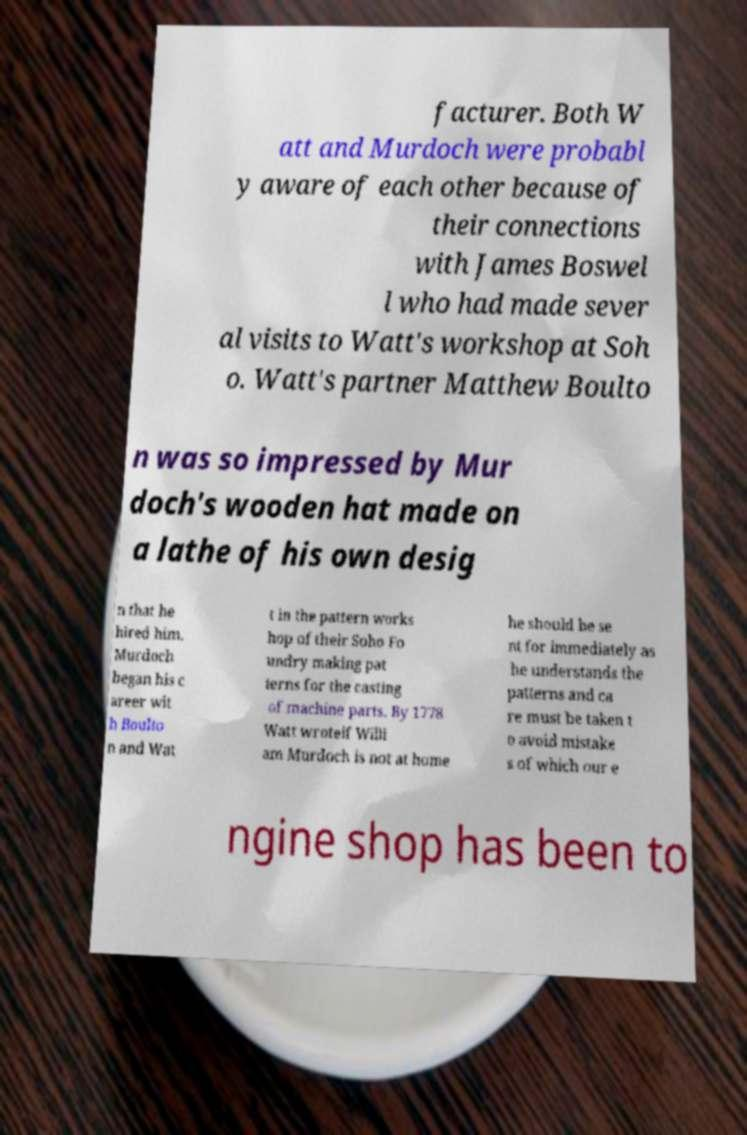There's text embedded in this image that I need extracted. Can you transcribe it verbatim? facturer. Both W att and Murdoch were probabl y aware of each other because of their connections with James Boswel l who had made sever al visits to Watt's workshop at Soh o. Watt's partner Matthew Boulto n was so impressed by Mur doch's wooden hat made on a lathe of his own desig n that he hired him. Murdoch began his c areer wit h Boulto n and Wat t in the pattern works hop of their Soho Fo undry making pat terns for the casting of machine parts. By 1778 Watt wroteif Willi am Murdoch is not at home he should be se nt for immediately as he understands the patterns and ca re must be taken t o avoid mistake s of which our e ngine shop has been to 